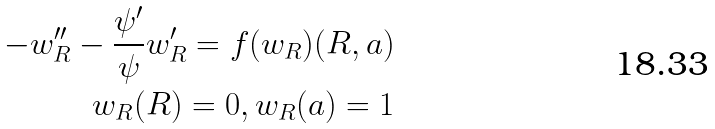<formula> <loc_0><loc_0><loc_500><loc_500>- w _ { R } ^ { \prime \prime } - \frac { \psi ^ { \prime } } { \psi } w _ { R } ^ { \prime } = f ( w _ { R } ) ( R , a ) \\ w _ { R } ( R ) = 0 , w _ { R } ( a ) = 1</formula> 